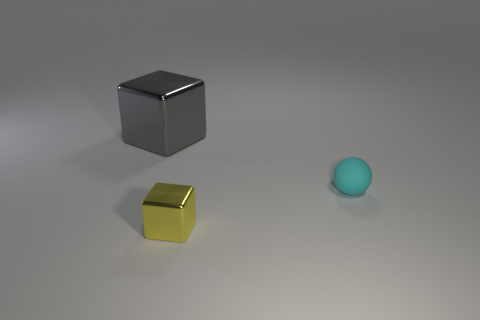Are there any other things that are the same size as the gray shiny object?
Your answer should be compact. No. What number of brown objects are either small objects or small rubber spheres?
Give a very brief answer. 0. There is a cyan thing in front of the large gray block; what is it made of?
Provide a succinct answer. Rubber. Are the cube on the right side of the gray thing and the big cube made of the same material?
Offer a terse response. Yes. The small cyan rubber thing has what shape?
Give a very brief answer. Sphere. What number of small cyan objects are to the right of the metallic cube that is in front of the object that is behind the tiny rubber ball?
Your answer should be compact. 1. How many other things are the same material as the big gray cube?
Your response must be concise. 1. What is the material of the cyan ball that is the same size as the yellow object?
Provide a short and direct response. Rubber. Is there another tiny rubber thing of the same shape as the cyan thing?
Offer a very short reply. No. What is the shape of the object that is the same size as the sphere?
Ensure brevity in your answer.  Cube. 